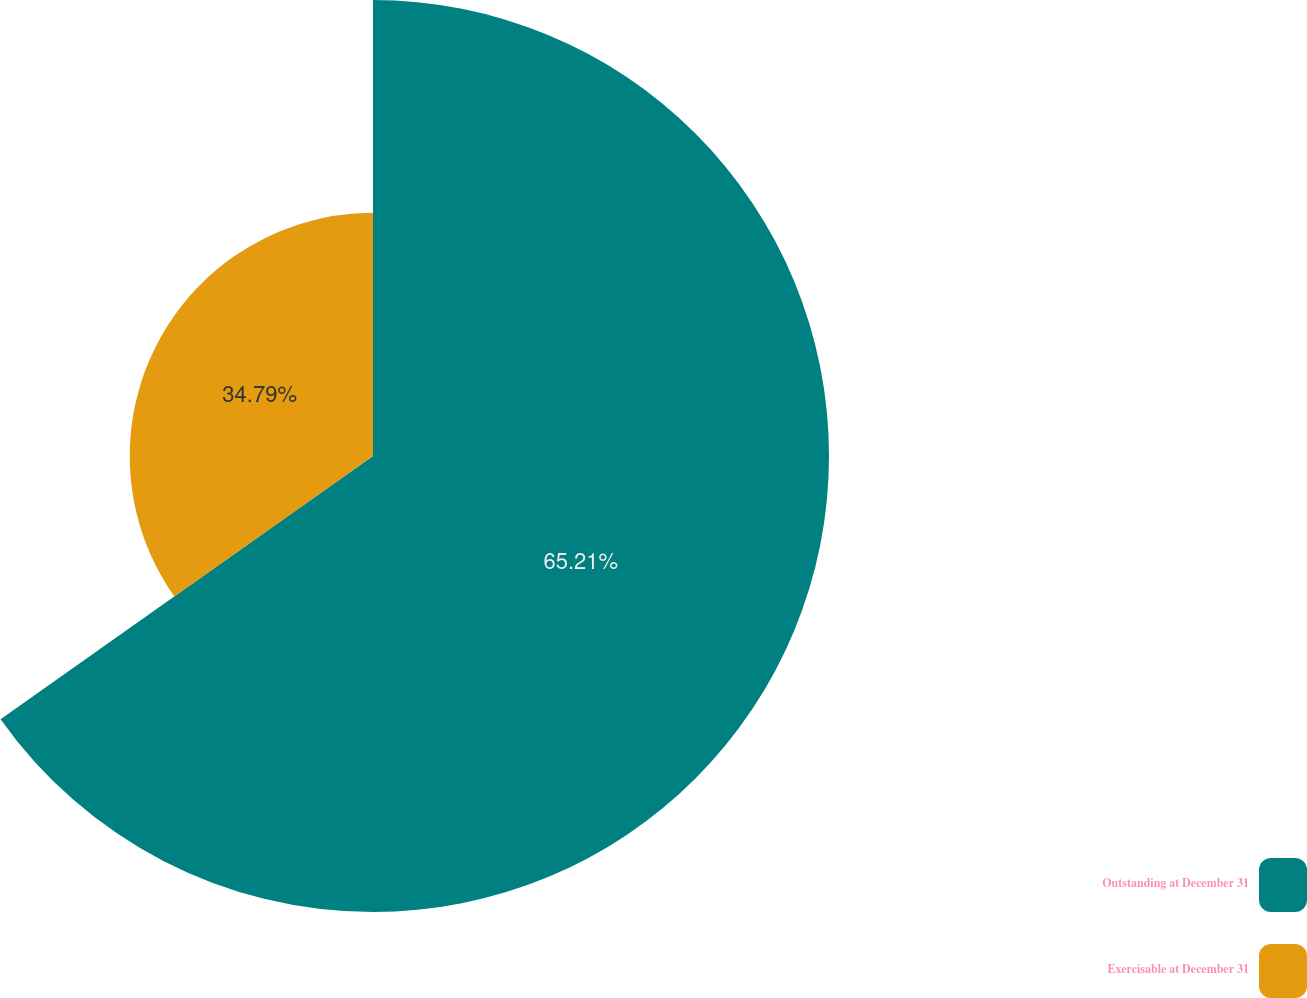Convert chart to OTSL. <chart><loc_0><loc_0><loc_500><loc_500><pie_chart><fcel>Outstanding at December 31<fcel>Exercisable at December 31<nl><fcel>65.21%<fcel>34.79%<nl></chart> 